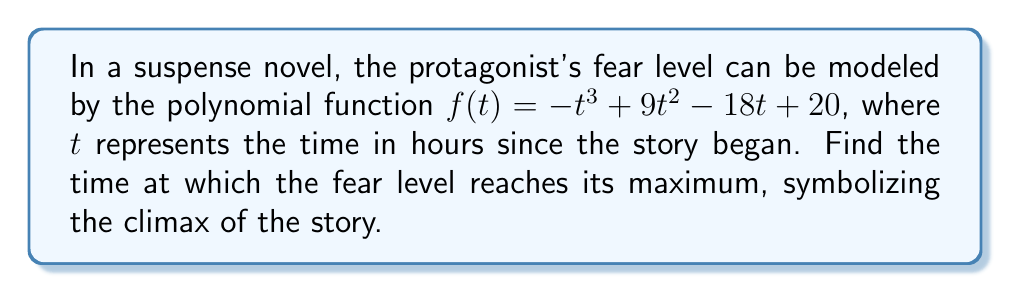Can you answer this question? To find the maximum point of the polynomial function, we need to follow these steps:

1) First, we find the derivative of the function:
   $f'(t) = -3t^2 + 18t - 18$

2) Set the derivative equal to zero to find critical points:
   $-3t^2 + 18t - 18 = 0$

3) Factor the equation:
   $-3(t^2 - 6t + 6) = 0$
   $-3(t - 3)^2 = 0$

4) Solve for t:
   $(t - 3)^2 = 0$
   $t - 3 = 0$
   $t = 3$

5) To confirm this is a maximum, we can check the second derivative:
   $f''(t) = -6t + 18$
   $f''(3) = -6(3) + 18 = 0$

   Since the second derivative is negative at $t=3$, this confirms it's a maximum point.

6) Therefore, the fear level reaches its maximum at $t = 3$ hours into the story, representing the climactic moment of suspense.
Answer: 3 hours 